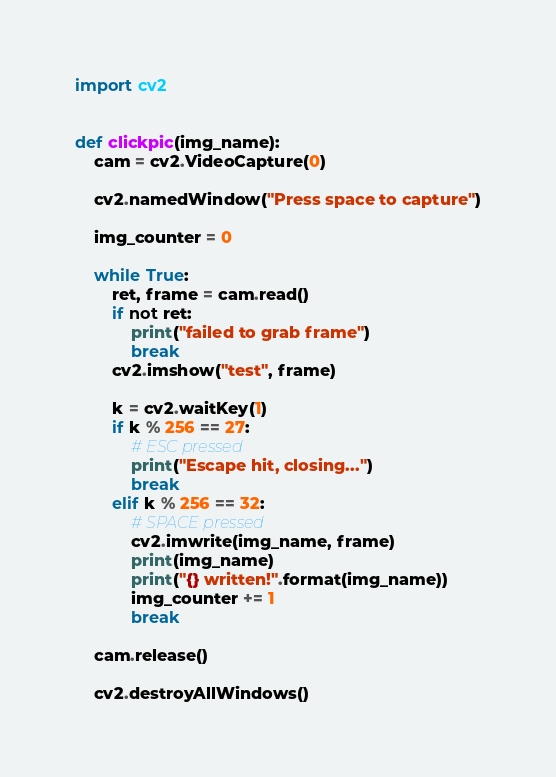Convert code to text. <code><loc_0><loc_0><loc_500><loc_500><_Python_>import cv2


def clickpic(img_name):
    cam = cv2.VideoCapture(0)

    cv2.namedWindow("Press space to capture")

    img_counter = 0

    while True:
        ret, frame = cam.read()
        if not ret:
            print("failed to grab frame")
            break
        cv2.imshow("test", frame)

        k = cv2.waitKey(1)
        if k % 256 == 27:
            # ESC pressed
            print("Escape hit, closing...")
            break
        elif k % 256 == 32:
            # SPACE pressed
            cv2.imwrite(img_name, frame)
            print(img_name)
            print("{} written!".format(img_name))
            img_counter += 1
            break

    cam.release()

    cv2.destroyAllWindows()
</code> 